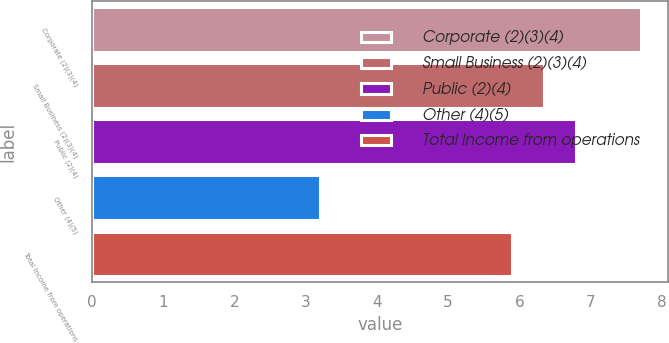Convert chart to OTSL. <chart><loc_0><loc_0><loc_500><loc_500><bar_chart><fcel>Corporate (2)(3)(4)<fcel>Small Business (2)(3)(4)<fcel>Public (2)(4)<fcel>Other (4)(5)<fcel>Total Income from operations<nl><fcel>7.7<fcel>6.35<fcel>6.8<fcel>3.2<fcel>5.9<nl></chart> 